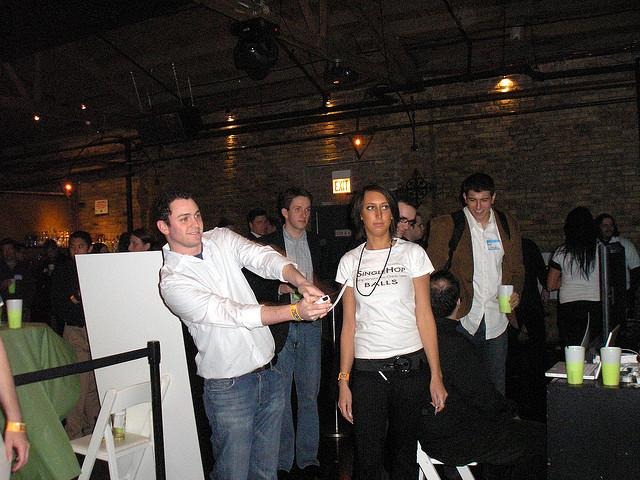Why is the man swinging his arm? Please explain your reasoning. to control. The man is trying to hit something 